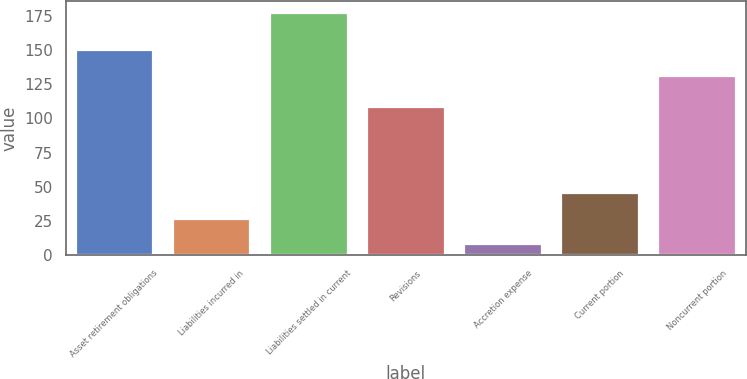Convert chart to OTSL. <chart><loc_0><loc_0><loc_500><loc_500><bar_chart><fcel>Asset retirement obligations<fcel>Liabilities incurred in<fcel>Liabilities settled in current<fcel>Revisions<fcel>Accretion expense<fcel>Current portion<fcel>Noncurrent portion<nl><fcel>149.8<fcel>26.8<fcel>177<fcel>108<fcel>8<fcel>45.6<fcel>131<nl></chart> 